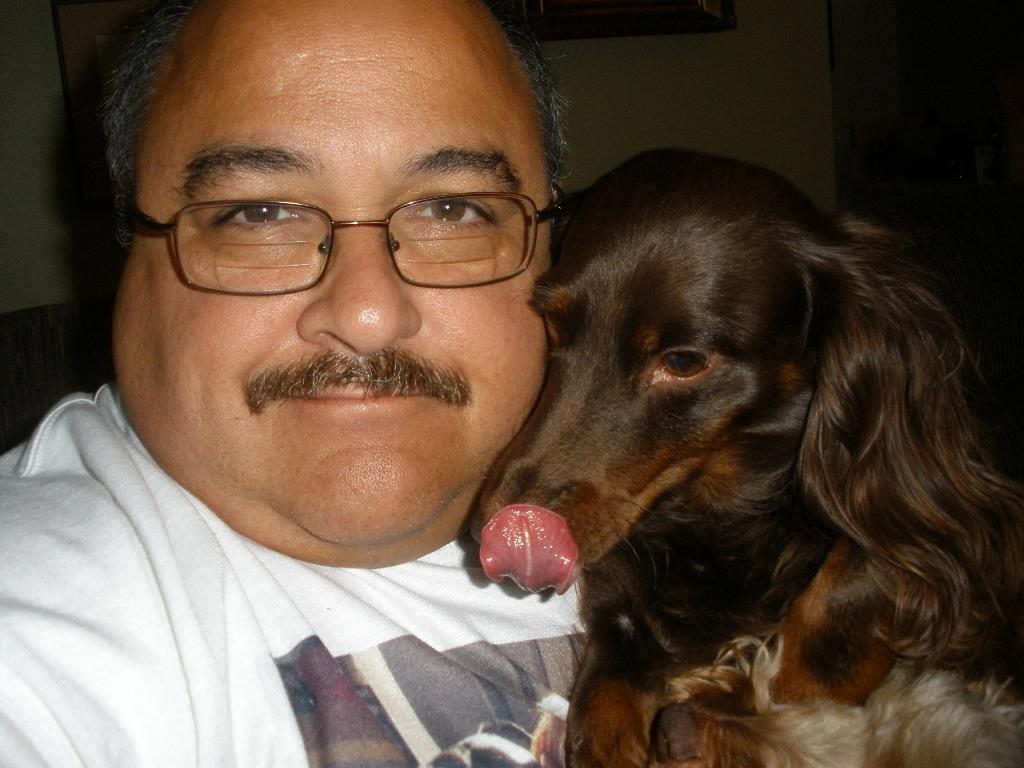Who is present in the image? There is a man in the image. What is the man wearing on his face? The man is wearing spectacles. What is the man wearing on his upper body? The man is wearing a white t-shirt. What is the man's facial expression? The man is smiling. What type of animal is beside the man? There is a dog beside the man. What can be seen in the background of the image? There is a wall in the background of the image. How many apples are on the bed in the image? There are no apples or beds present in the image. What type of sea creature can be seen swimming in the background of the image? There is no sea or sea creature visible in the image; it features a man, a dog, and a wall in the background. 